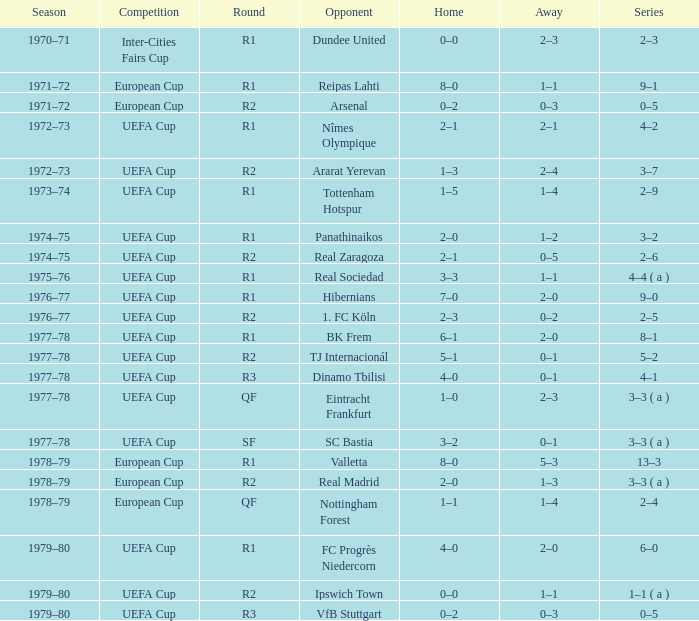Which Series has a Home of 2–0, and an Opponent of panathinaikos? 3–2. 